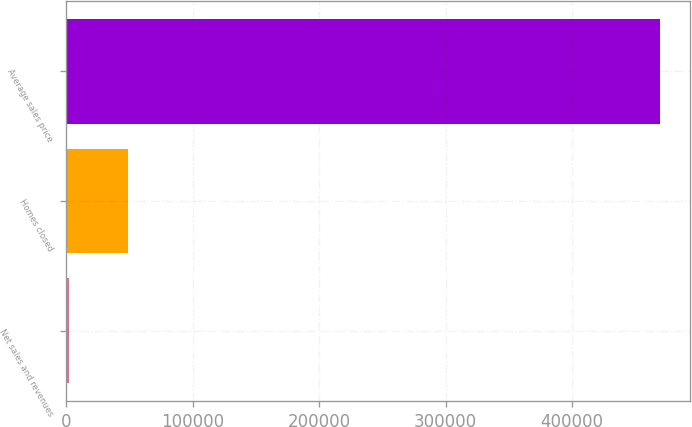Convert chart. <chart><loc_0><loc_0><loc_500><loc_500><bar_chart><fcel>Net sales and revenues<fcel>Homes closed<fcel>Average sales price<nl><fcel>2079<fcel>48871.1<fcel>470000<nl></chart> 